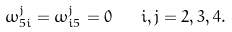<formula> <loc_0><loc_0><loc_500><loc_500>\omega _ { 5 i } ^ { j } = \omega _ { i 5 } ^ { j } = 0 \quad i , j = 2 , 3 , 4 .</formula> 